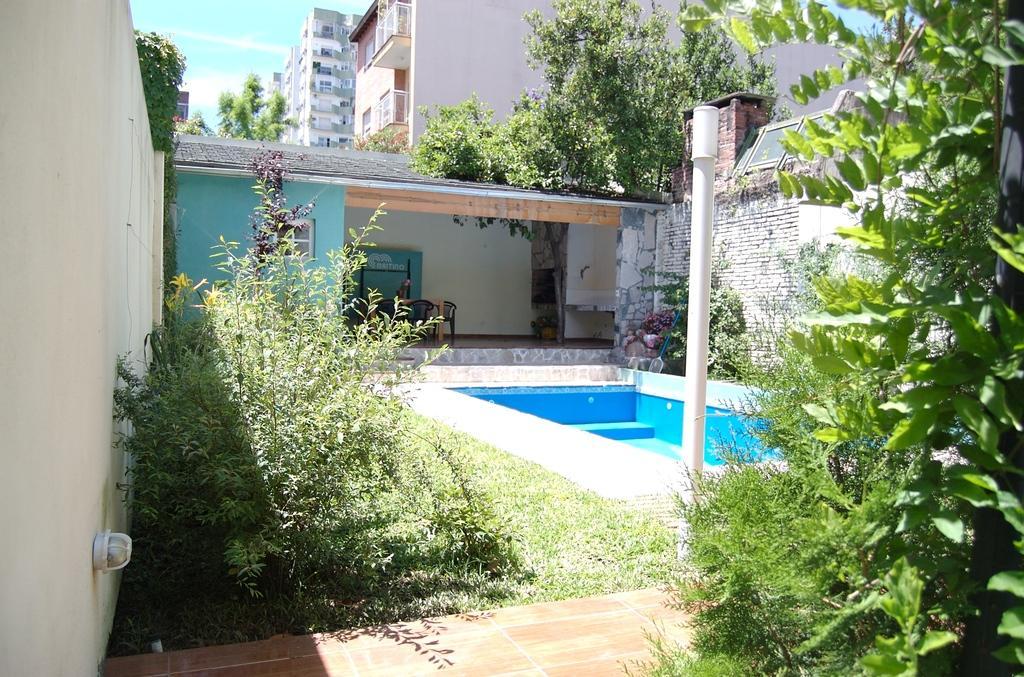Please provide a concise description of this image. In this picture we can see trees, pole, walls, grass, chairs, house with a window, buildings, stones and in the background we can see the sky. 